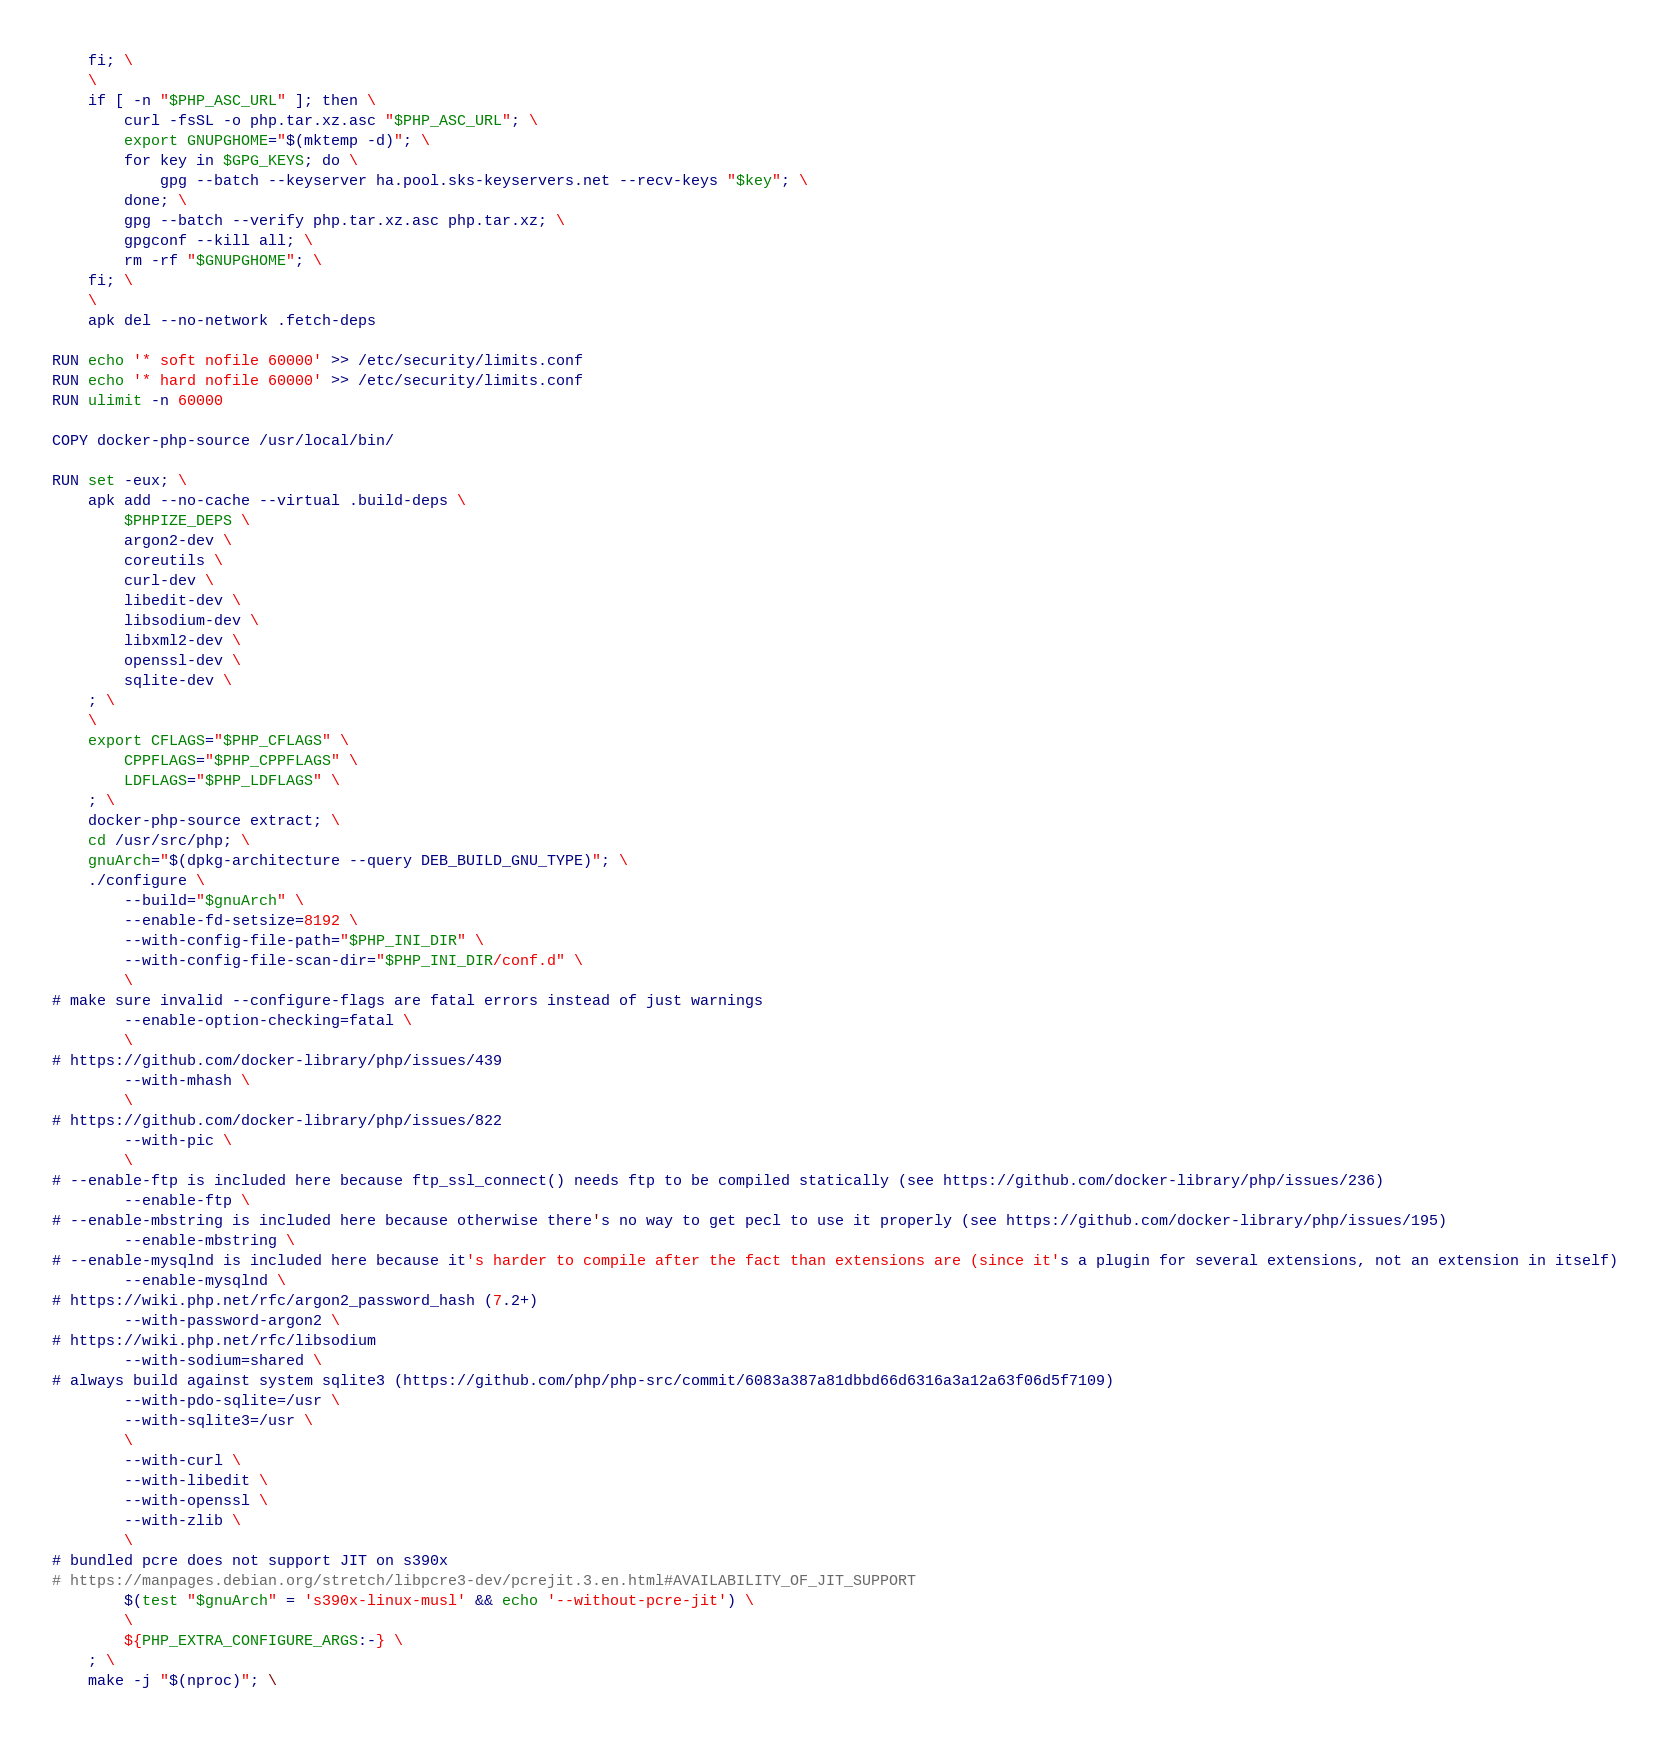<code> <loc_0><loc_0><loc_500><loc_500><_Dockerfile_>	fi; \
	\
	if [ -n "$PHP_ASC_URL" ]; then \
		curl -fsSL -o php.tar.xz.asc "$PHP_ASC_URL"; \
		export GNUPGHOME="$(mktemp -d)"; \
		for key in $GPG_KEYS; do \
			gpg --batch --keyserver ha.pool.sks-keyservers.net --recv-keys "$key"; \
		done; \
		gpg --batch --verify php.tar.xz.asc php.tar.xz; \
		gpgconf --kill all; \
		rm -rf "$GNUPGHOME"; \
	fi; \
	\
	apk del --no-network .fetch-deps

RUN echo '* soft nofile 60000' >> /etc/security/limits.conf
RUN echo '* hard nofile 60000' >> /etc/security/limits.conf
RUN ulimit -n 60000

COPY docker-php-source /usr/local/bin/

RUN set -eux; \
	apk add --no-cache --virtual .build-deps \
		$PHPIZE_DEPS \
		argon2-dev \
		coreutils \
		curl-dev \
		libedit-dev \
		libsodium-dev \
		libxml2-dev \
		openssl-dev \
		sqlite-dev \
	; \
	\
	export CFLAGS="$PHP_CFLAGS" \
		CPPFLAGS="$PHP_CPPFLAGS" \
		LDFLAGS="$PHP_LDFLAGS" \
	; \
	docker-php-source extract; \
	cd /usr/src/php; \
	gnuArch="$(dpkg-architecture --query DEB_BUILD_GNU_TYPE)"; \
	./configure \
		--build="$gnuArch" \
		--enable-fd-setsize=8192 \
		--with-config-file-path="$PHP_INI_DIR" \
		--with-config-file-scan-dir="$PHP_INI_DIR/conf.d" \
		\
# make sure invalid --configure-flags are fatal errors instead of just warnings
		--enable-option-checking=fatal \
		\
# https://github.com/docker-library/php/issues/439
		--with-mhash \
		\
# https://github.com/docker-library/php/issues/822
		--with-pic \
		\
# --enable-ftp is included here because ftp_ssl_connect() needs ftp to be compiled statically (see https://github.com/docker-library/php/issues/236)
		--enable-ftp \
# --enable-mbstring is included here because otherwise there's no way to get pecl to use it properly (see https://github.com/docker-library/php/issues/195)
		--enable-mbstring \
# --enable-mysqlnd is included here because it's harder to compile after the fact than extensions are (since it's a plugin for several extensions, not an extension in itself)
		--enable-mysqlnd \
# https://wiki.php.net/rfc/argon2_password_hash (7.2+)
		--with-password-argon2 \
# https://wiki.php.net/rfc/libsodium
		--with-sodium=shared \
# always build against system sqlite3 (https://github.com/php/php-src/commit/6083a387a81dbbd66d6316a3a12a63f06d5f7109)
		--with-pdo-sqlite=/usr \
		--with-sqlite3=/usr \
		\
		--with-curl \
		--with-libedit \
		--with-openssl \
		--with-zlib \
		\
# bundled pcre does not support JIT on s390x
# https://manpages.debian.org/stretch/libpcre3-dev/pcrejit.3.en.html#AVAILABILITY_OF_JIT_SUPPORT
		$(test "$gnuArch" = 's390x-linux-musl' && echo '--without-pcre-jit') \
		\
		${PHP_EXTRA_CONFIGURE_ARGS:-} \
	; \
	make -j "$(nproc)"; \</code> 